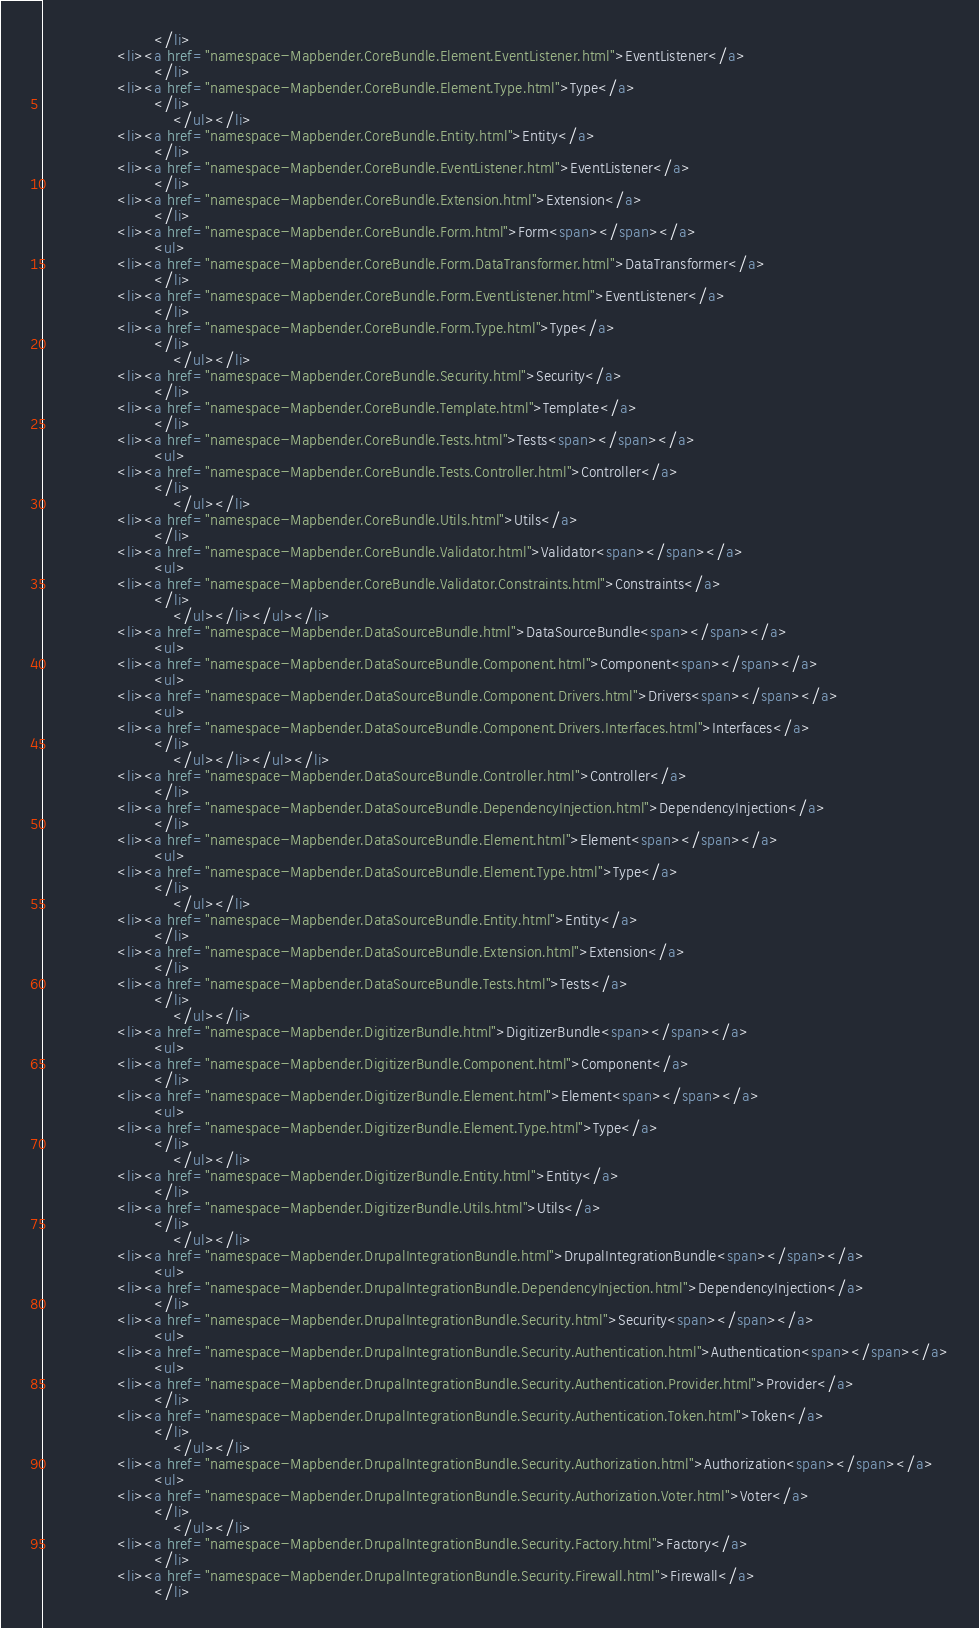Convert code to text. <code><loc_0><loc_0><loc_500><loc_500><_HTML_>						</li>
				<li><a href="namespace-Mapbender.CoreBundle.Element.EventListener.html">EventListener</a>
						</li>
				<li><a href="namespace-Mapbender.CoreBundle.Element.Type.html">Type</a>
						</li>
							</ul></li>
				<li><a href="namespace-Mapbender.CoreBundle.Entity.html">Entity</a>
						</li>
				<li><a href="namespace-Mapbender.CoreBundle.EventListener.html">EventListener</a>
						</li>
				<li><a href="namespace-Mapbender.CoreBundle.Extension.html">Extension</a>
						</li>
				<li><a href="namespace-Mapbender.CoreBundle.Form.html">Form<span></span></a>
						<ul>
				<li><a href="namespace-Mapbender.CoreBundle.Form.DataTransformer.html">DataTransformer</a>
						</li>
				<li><a href="namespace-Mapbender.CoreBundle.Form.EventListener.html">EventListener</a>
						</li>
				<li><a href="namespace-Mapbender.CoreBundle.Form.Type.html">Type</a>
						</li>
							</ul></li>
				<li><a href="namespace-Mapbender.CoreBundle.Security.html">Security</a>
						</li>
				<li><a href="namespace-Mapbender.CoreBundle.Template.html">Template</a>
						</li>
				<li><a href="namespace-Mapbender.CoreBundle.Tests.html">Tests<span></span></a>
						<ul>
				<li><a href="namespace-Mapbender.CoreBundle.Tests.Controller.html">Controller</a>
						</li>
							</ul></li>
				<li><a href="namespace-Mapbender.CoreBundle.Utils.html">Utils</a>
						</li>
				<li><a href="namespace-Mapbender.CoreBundle.Validator.html">Validator<span></span></a>
						<ul>
				<li><a href="namespace-Mapbender.CoreBundle.Validator.Constraints.html">Constraints</a>
						</li>
							</ul></li></ul></li>
				<li><a href="namespace-Mapbender.DataSourceBundle.html">DataSourceBundle<span></span></a>
						<ul>
				<li><a href="namespace-Mapbender.DataSourceBundle.Component.html">Component<span></span></a>
						<ul>
				<li><a href="namespace-Mapbender.DataSourceBundle.Component.Drivers.html">Drivers<span></span></a>
						<ul>
				<li><a href="namespace-Mapbender.DataSourceBundle.Component.Drivers.Interfaces.html">Interfaces</a>
						</li>
							</ul></li></ul></li>
				<li><a href="namespace-Mapbender.DataSourceBundle.Controller.html">Controller</a>
						</li>
				<li><a href="namespace-Mapbender.DataSourceBundle.DependencyInjection.html">DependencyInjection</a>
						</li>
				<li><a href="namespace-Mapbender.DataSourceBundle.Element.html">Element<span></span></a>
						<ul>
				<li><a href="namespace-Mapbender.DataSourceBundle.Element.Type.html">Type</a>
						</li>
							</ul></li>
				<li><a href="namespace-Mapbender.DataSourceBundle.Entity.html">Entity</a>
						</li>
				<li><a href="namespace-Mapbender.DataSourceBundle.Extension.html">Extension</a>
						</li>
				<li><a href="namespace-Mapbender.DataSourceBundle.Tests.html">Tests</a>
						</li>
							</ul></li>
				<li><a href="namespace-Mapbender.DigitizerBundle.html">DigitizerBundle<span></span></a>
						<ul>
				<li><a href="namespace-Mapbender.DigitizerBundle.Component.html">Component</a>
						</li>
				<li><a href="namespace-Mapbender.DigitizerBundle.Element.html">Element<span></span></a>
						<ul>
				<li><a href="namespace-Mapbender.DigitizerBundle.Element.Type.html">Type</a>
						</li>
							</ul></li>
				<li><a href="namespace-Mapbender.DigitizerBundle.Entity.html">Entity</a>
						</li>
				<li><a href="namespace-Mapbender.DigitizerBundle.Utils.html">Utils</a>
						</li>
							</ul></li>
				<li><a href="namespace-Mapbender.DrupalIntegrationBundle.html">DrupalIntegrationBundle<span></span></a>
						<ul>
				<li><a href="namespace-Mapbender.DrupalIntegrationBundle.DependencyInjection.html">DependencyInjection</a>
						</li>
				<li><a href="namespace-Mapbender.DrupalIntegrationBundle.Security.html">Security<span></span></a>
						<ul>
				<li><a href="namespace-Mapbender.DrupalIntegrationBundle.Security.Authentication.html">Authentication<span></span></a>
						<ul>
				<li><a href="namespace-Mapbender.DrupalIntegrationBundle.Security.Authentication.Provider.html">Provider</a>
						</li>
				<li><a href="namespace-Mapbender.DrupalIntegrationBundle.Security.Authentication.Token.html">Token</a>
						</li>
							</ul></li>
				<li><a href="namespace-Mapbender.DrupalIntegrationBundle.Security.Authorization.html">Authorization<span></span></a>
						<ul>
				<li><a href="namespace-Mapbender.DrupalIntegrationBundle.Security.Authorization.Voter.html">Voter</a>
						</li>
							</ul></li>
				<li><a href="namespace-Mapbender.DrupalIntegrationBundle.Security.Factory.html">Factory</a>
						</li>
				<li><a href="namespace-Mapbender.DrupalIntegrationBundle.Security.Firewall.html">Firewall</a>
						</li></code> 